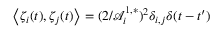Convert formula to latex. <formula><loc_0><loc_0><loc_500><loc_500>\left \langle \zeta _ { i } ( t ) , \zeta _ { j } ( t ) \right \rangle = ( 2 / \mathcal { A } _ { i } ^ { 1 , * } ) ^ { 2 } \delta _ { i , j } \delta ( t - t ^ { \prime } )</formula> 